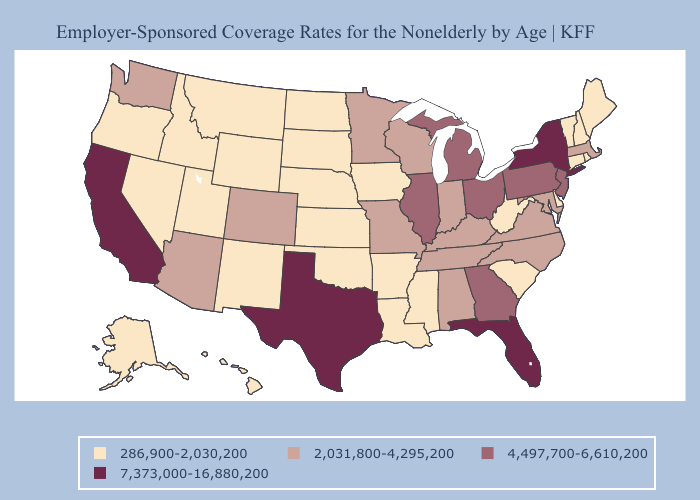Does the map have missing data?
Answer briefly. No. Does Illinois have a higher value than New Jersey?
Write a very short answer. No. Name the states that have a value in the range 2,031,800-4,295,200?
Answer briefly. Alabama, Arizona, Colorado, Indiana, Kentucky, Maryland, Massachusetts, Minnesota, Missouri, North Carolina, Tennessee, Virginia, Washington, Wisconsin. Name the states that have a value in the range 7,373,000-16,880,200?
Be succinct. California, Florida, New York, Texas. What is the value of Colorado?
Be succinct. 2,031,800-4,295,200. What is the value of Pennsylvania?
Short answer required. 4,497,700-6,610,200. Name the states that have a value in the range 4,497,700-6,610,200?
Keep it brief. Georgia, Illinois, Michigan, New Jersey, Ohio, Pennsylvania. What is the value of Utah?
Answer briefly. 286,900-2,030,200. Which states have the lowest value in the MidWest?
Answer briefly. Iowa, Kansas, Nebraska, North Dakota, South Dakota. What is the value of Utah?
Concise answer only. 286,900-2,030,200. What is the value of New York?
Concise answer only. 7,373,000-16,880,200. What is the value of Kentucky?
Answer briefly. 2,031,800-4,295,200. Does North Dakota have the lowest value in the USA?
Write a very short answer. Yes. Does North Dakota have the lowest value in the USA?
Keep it brief. Yes. Which states hav the highest value in the MidWest?
Write a very short answer. Illinois, Michigan, Ohio. 